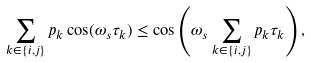Convert formula to latex. <formula><loc_0><loc_0><loc_500><loc_500>\sum _ { k \in \{ i , j \} } p _ { k } \cos ( \omega _ { s } \tau _ { k } ) \leq \cos \left ( \omega _ { s } \sum _ { k \in \{ i , j \} } p _ { k } \tau _ { k } \right ) ,</formula> 